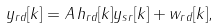<formula> <loc_0><loc_0><loc_500><loc_500>y _ { r d } [ k ] = A \, h _ { r d } [ k ] y _ { s r } [ k ] + w _ { r d } [ k ] ,</formula> 